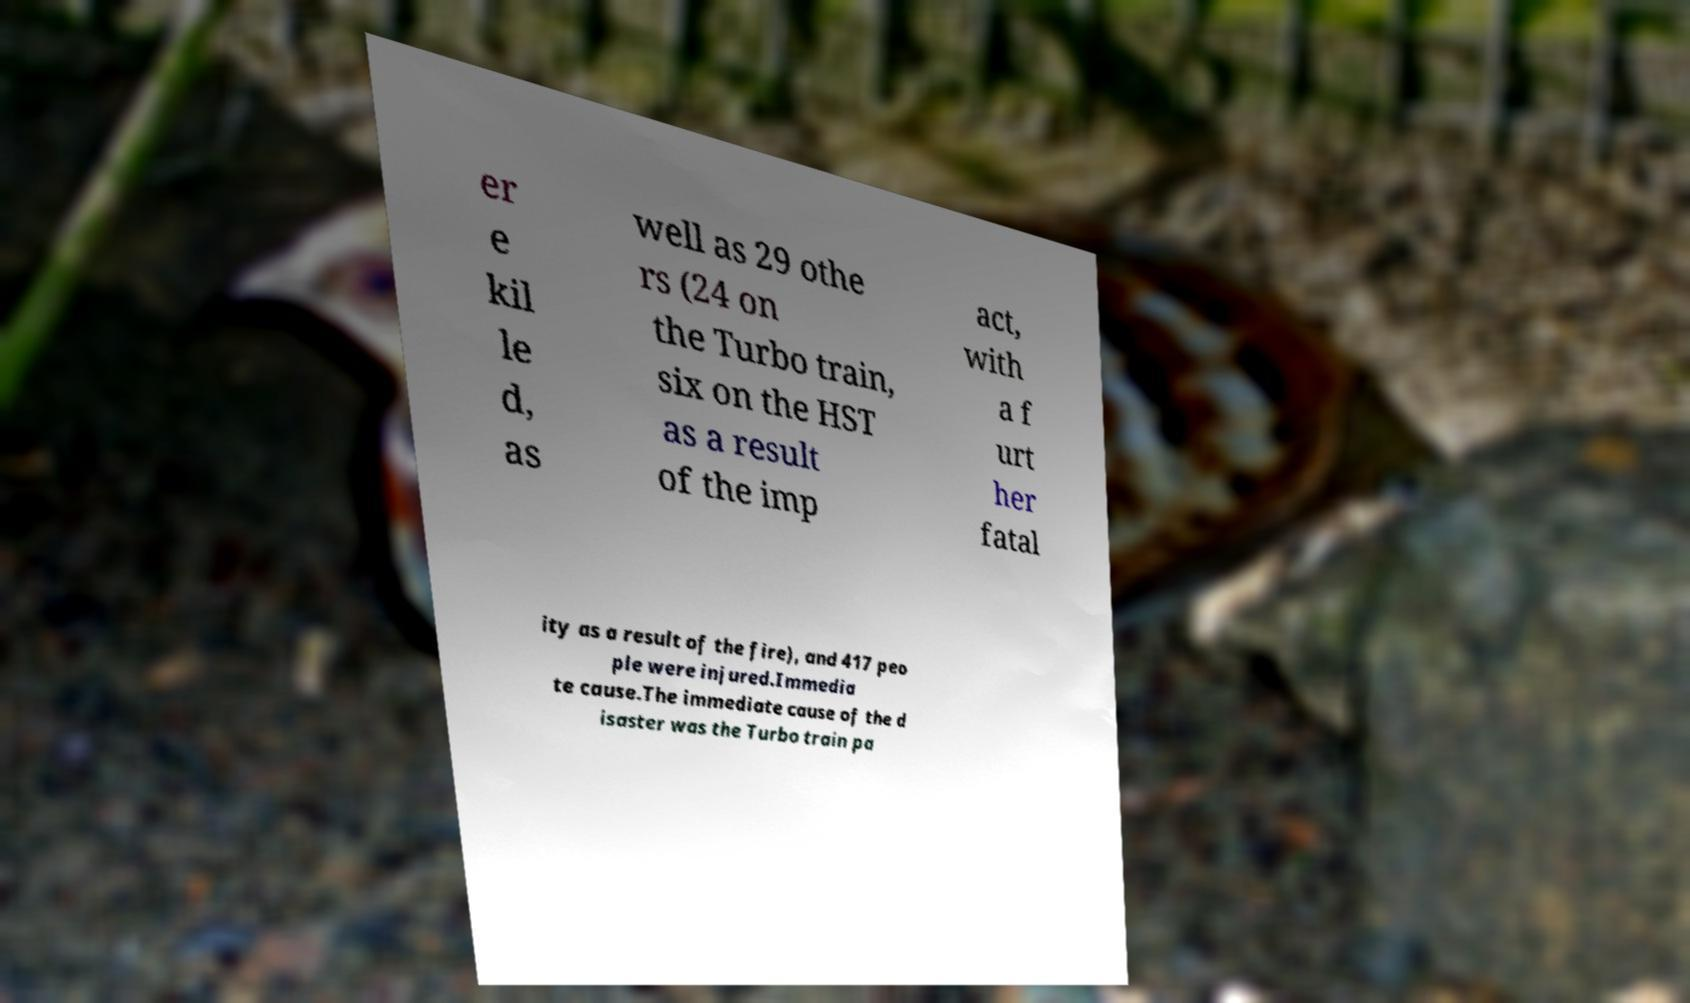I need the written content from this picture converted into text. Can you do that? er e kil le d, as well as 29 othe rs (24 on the Turbo train, six on the HST as a result of the imp act, with a f urt her fatal ity as a result of the fire), and 417 peo ple were injured.Immedia te cause.The immediate cause of the d isaster was the Turbo train pa 